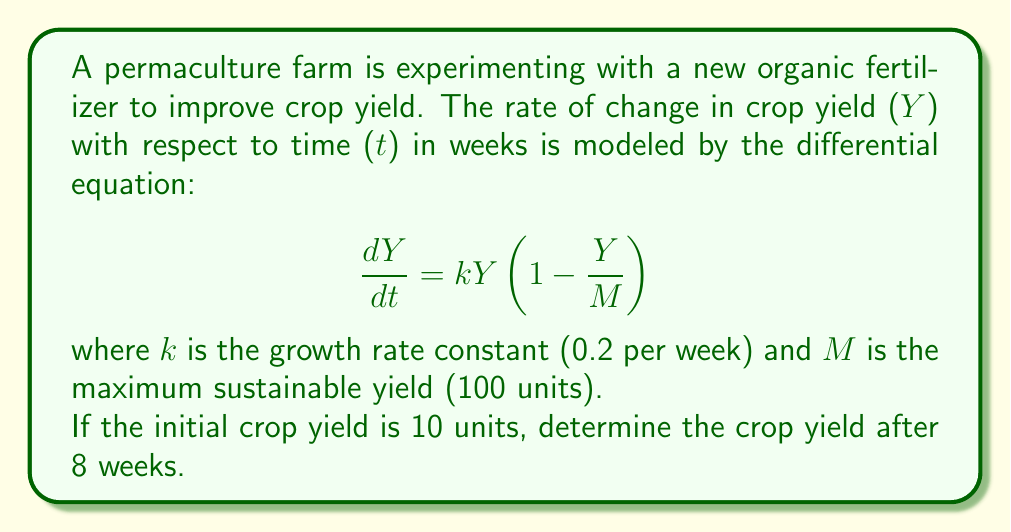Solve this math problem. To solve this problem, we need to use the logistic growth model, which is described by the given differential equation. Let's approach this step-by-step:

1) The differential equation is in the form of the logistic growth model:

   $$\frac{dY}{dt} = kY(1 - \frac{Y}{M})$$

2) The solution to this equation is:

   $$Y(t) = \frac{M}{1 + (\frac{M}{Y_0} - 1)e^{-kt}}$$

   where $Y_0$ is the initial yield.

3) We're given the following values:
   - k = 0.2 per week
   - M = 100 units
   - $Y_0$ = 10 units
   - t = 8 weeks

4) Let's substitute these values into our solution:

   $$Y(8) = \frac{100}{1 + (\frac{100}{10} - 1)e^{-0.2(8)}}$$

5) Simplify:
   $$Y(8) = \frac{100}{1 + 9e^{-1.6}}$$

6) Calculate $e^{-1.6}$:
   $$e^{-1.6} \approx 0.2019$$

7) Substitute this value:
   $$Y(8) = \frac{100}{1 + 9(0.2019)} = \frac{100}{2.8171}$$

8) Calculate the final result:
   $$Y(8) \approx 35.50$$

Therefore, after 8 weeks, the crop yield will be approximately 35.50 units.
Answer: 35.50 units 